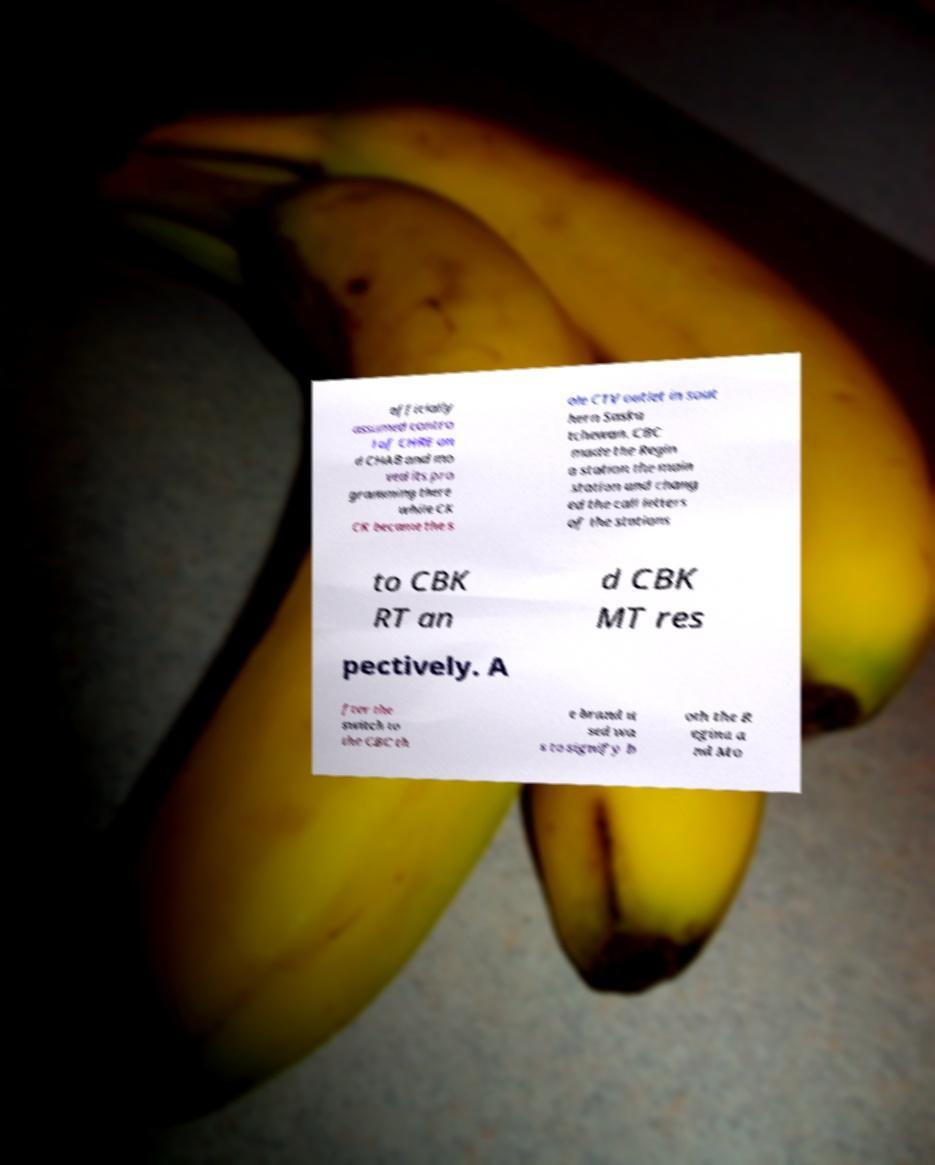Please read and relay the text visible in this image. What does it say? officially assumed contro l of CHRE an d CHAB and mo ved its pro gramming there while CK CK became the s ole CTV outlet in sout hern Saska tchewan. CBC made the Regin a station the main station and chang ed the call letters of the stations to CBK RT an d CBK MT res pectively. A fter the switch to the CBC th e brand u sed wa s to signify b oth the R egina a nd Mo 